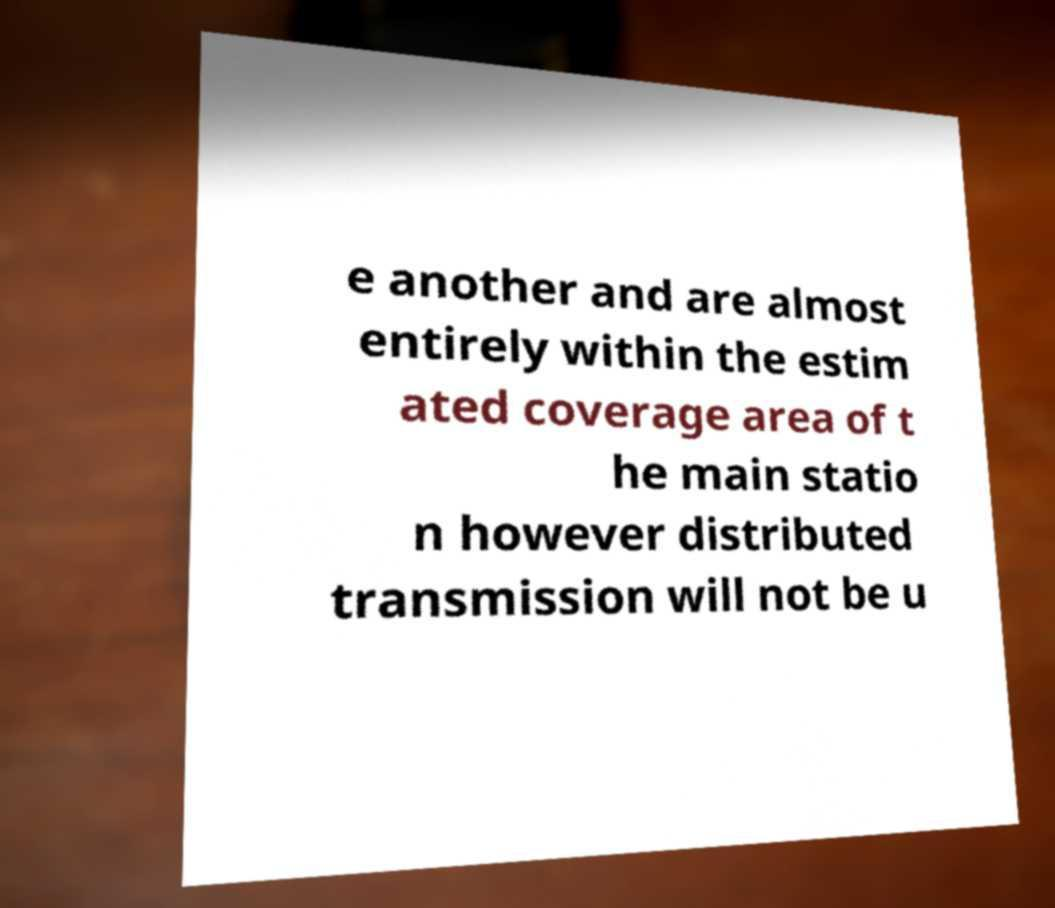Could you assist in decoding the text presented in this image and type it out clearly? e another and are almost entirely within the estim ated coverage area of t he main statio n however distributed transmission will not be u 